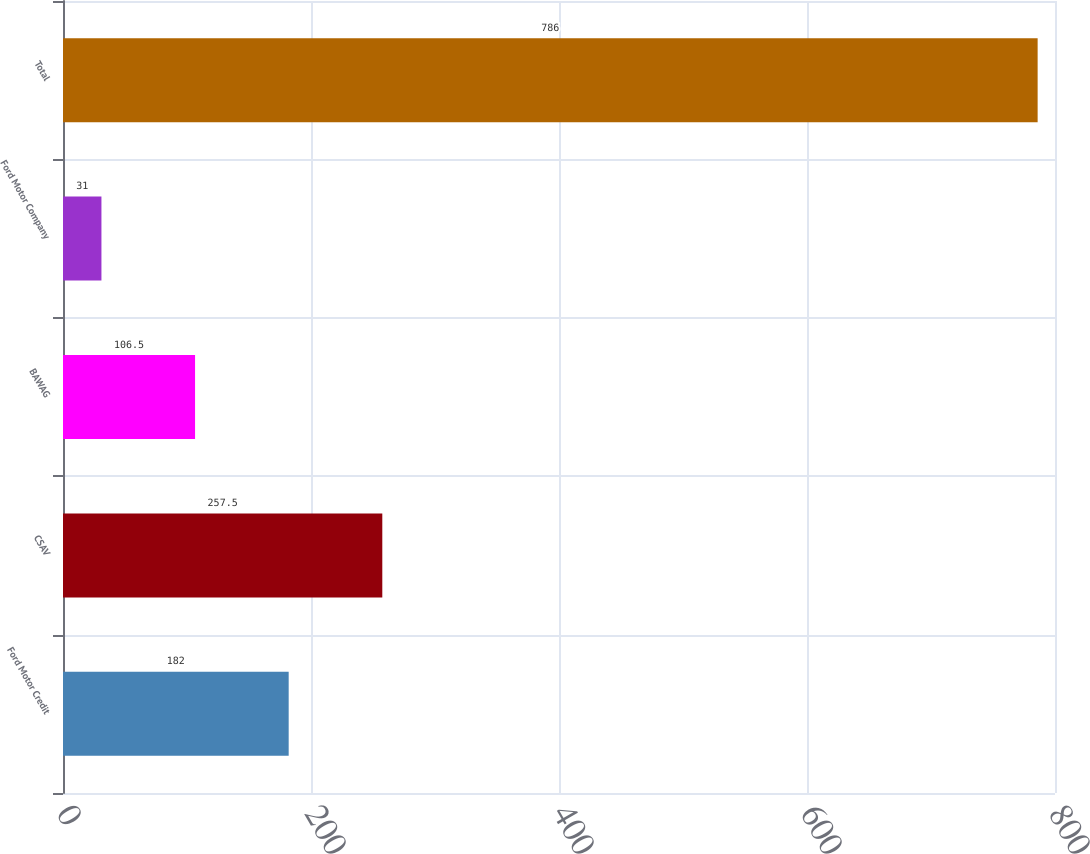<chart> <loc_0><loc_0><loc_500><loc_500><bar_chart><fcel>Ford Motor Credit<fcel>CSAV<fcel>BAWAG<fcel>Ford Motor Company<fcel>Total<nl><fcel>182<fcel>257.5<fcel>106.5<fcel>31<fcel>786<nl></chart> 